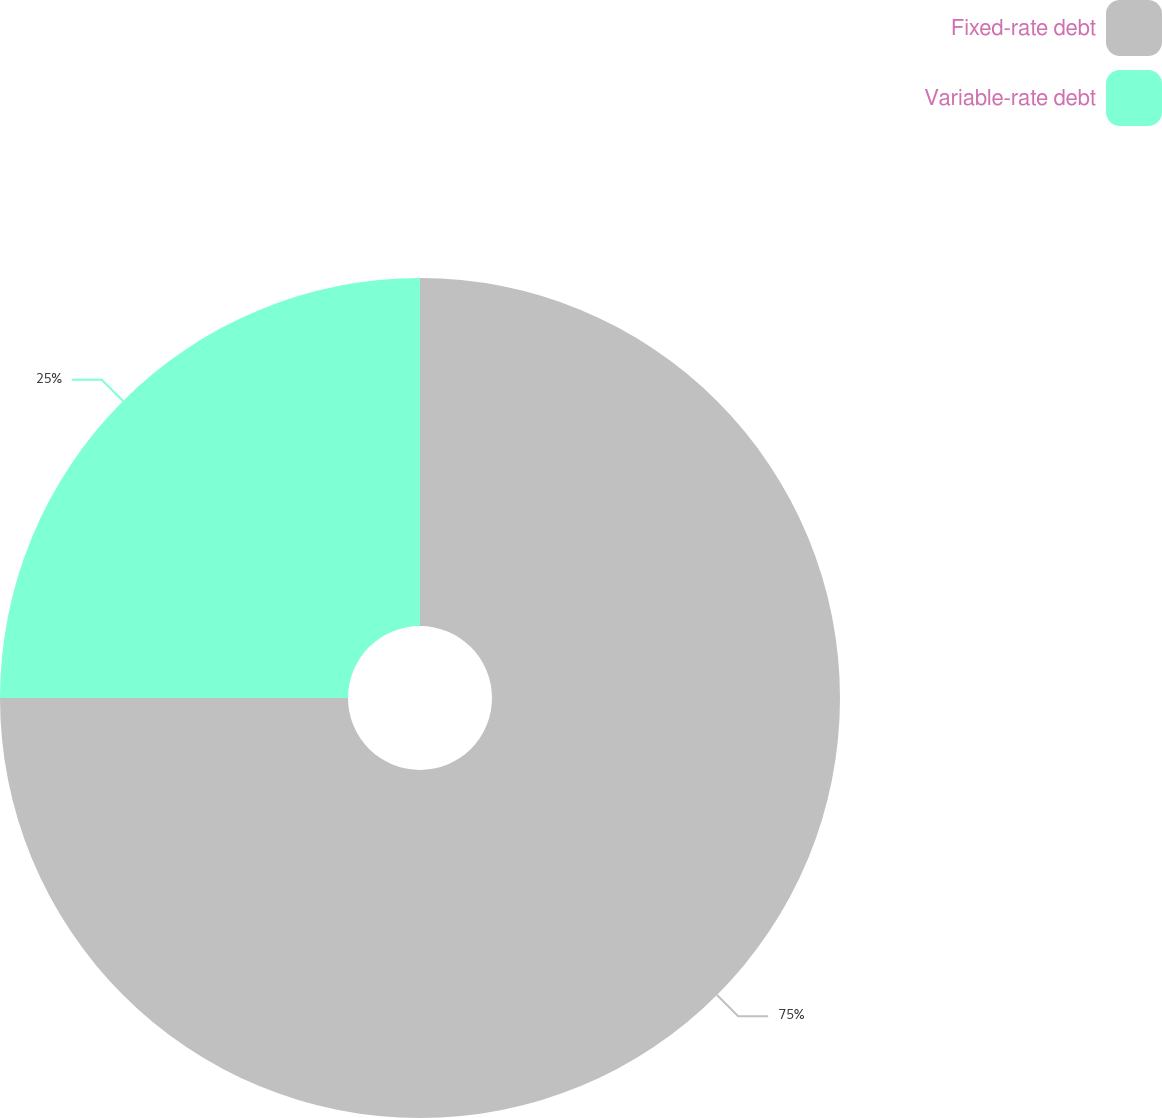Convert chart to OTSL. <chart><loc_0><loc_0><loc_500><loc_500><pie_chart><fcel>Fixed-rate debt<fcel>Variable-rate debt<nl><fcel>75.0%<fcel>25.0%<nl></chart> 